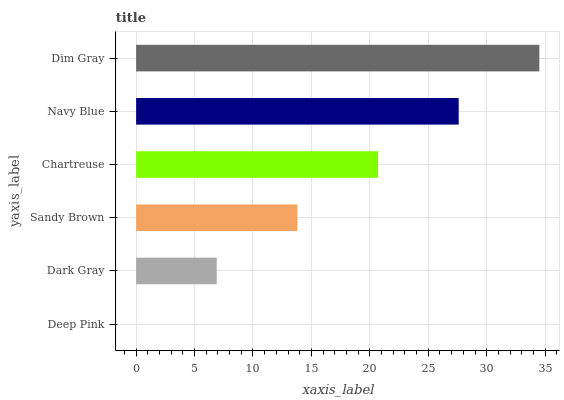Is Deep Pink the minimum?
Answer yes or no. Yes. Is Dim Gray the maximum?
Answer yes or no. Yes. Is Dark Gray the minimum?
Answer yes or no. No. Is Dark Gray the maximum?
Answer yes or no. No. Is Dark Gray greater than Deep Pink?
Answer yes or no. Yes. Is Deep Pink less than Dark Gray?
Answer yes or no. Yes. Is Deep Pink greater than Dark Gray?
Answer yes or no. No. Is Dark Gray less than Deep Pink?
Answer yes or no. No. Is Chartreuse the high median?
Answer yes or no. Yes. Is Sandy Brown the low median?
Answer yes or no. Yes. Is Dark Gray the high median?
Answer yes or no. No. Is Dim Gray the low median?
Answer yes or no. No. 